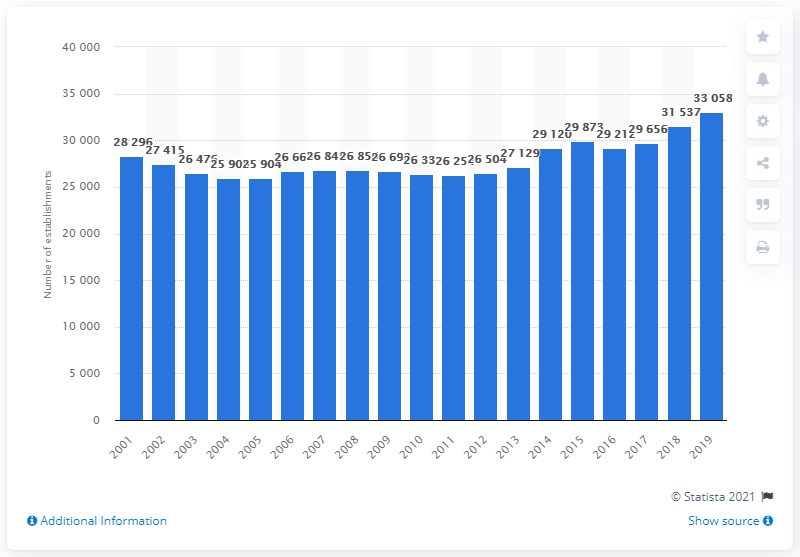Mention a couple of crucial points in this snapshot. Since 2016, the number of private establishments in the U.S. motion picture and sound recording industry has been on a general upward trend. 